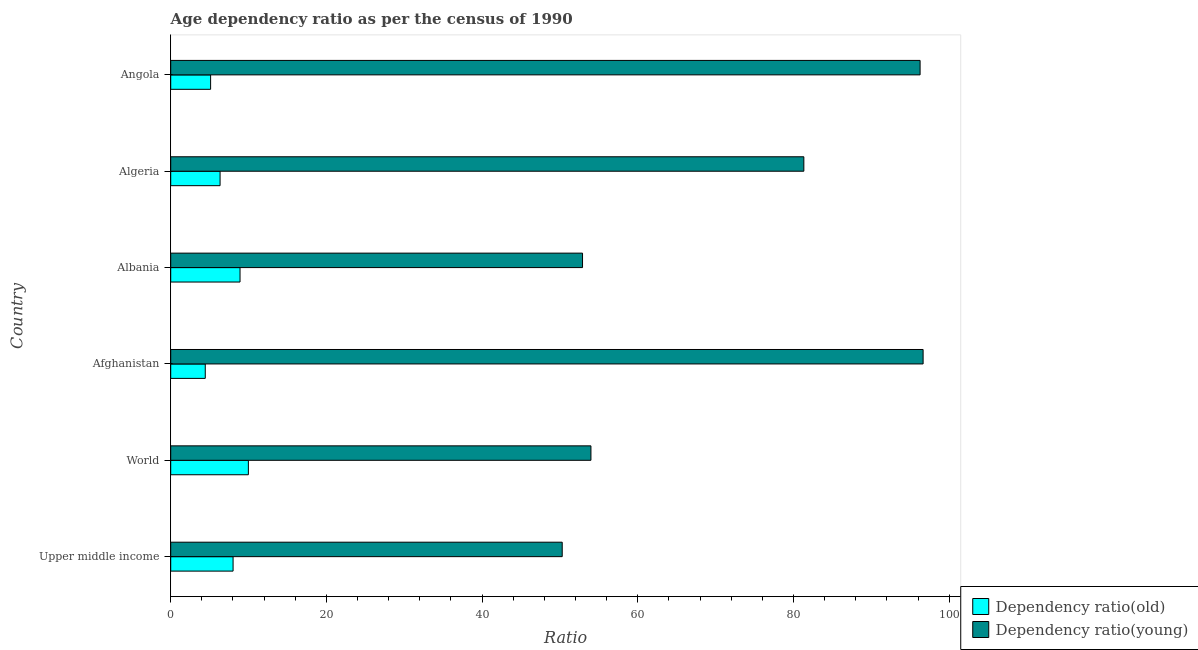How many different coloured bars are there?
Your answer should be compact. 2. What is the label of the 2nd group of bars from the top?
Your answer should be compact. Algeria. In how many cases, is the number of bars for a given country not equal to the number of legend labels?
Keep it short and to the point. 0. What is the age dependency ratio(old) in Algeria?
Your answer should be very brief. 6.34. Across all countries, what is the maximum age dependency ratio(young)?
Ensure brevity in your answer.  96.66. Across all countries, what is the minimum age dependency ratio(old)?
Offer a very short reply. 4.44. In which country was the age dependency ratio(young) maximum?
Ensure brevity in your answer.  Afghanistan. In which country was the age dependency ratio(young) minimum?
Provide a succinct answer. Upper middle income. What is the total age dependency ratio(young) in the graph?
Offer a terse response. 431.44. What is the difference between the age dependency ratio(old) in Albania and that in Algeria?
Keep it short and to the point. 2.56. What is the difference between the age dependency ratio(young) in Albania and the age dependency ratio(old) in Afghanistan?
Your answer should be compact. 48.47. What is the average age dependency ratio(young) per country?
Offer a very short reply. 71.91. What is the difference between the age dependency ratio(old) and age dependency ratio(young) in Angola?
Keep it short and to the point. -91.14. What is the ratio of the age dependency ratio(young) in Albania to that in Algeria?
Your answer should be very brief. 0.65. Is the age dependency ratio(young) in Afghanistan less than that in Upper middle income?
Offer a terse response. No. What is the difference between the highest and the second highest age dependency ratio(old)?
Provide a succinct answer. 1.07. What is the difference between the highest and the lowest age dependency ratio(old)?
Your answer should be very brief. 5.54. What does the 1st bar from the top in Upper middle income represents?
Give a very brief answer. Dependency ratio(young). What does the 2nd bar from the bottom in Upper middle income represents?
Your answer should be compact. Dependency ratio(young). Are all the bars in the graph horizontal?
Provide a succinct answer. Yes. How many countries are there in the graph?
Your answer should be compact. 6. What is the difference between two consecutive major ticks on the X-axis?
Ensure brevity in your answer.  20. Does the graph contain any zero values?
Ensure brevity in your answer.  No. Does the graph contain grids?
Offer a terse response. No. Where does the legend appear in the graph?
Ensure brevity in your answer.  Bottom right. How many legend labels are there?
Keep it short and to the point. 2. How are the legend labels stacked?
Keep it short and to the point. Vertical. What is the title of the graph?
Keep it short and to the point. Age dependency ratio as per the census of 1990. Does "Quality of trade" appear as one of the legend labels in the graph?
Offer a terse response. No. What is the label or title of the X-axis?
Provide a succinct answer. Ratio. What is the Ratio of Dependency ratio(old) in Upper middle income?
Your answer should be very brief. 8.01. What is the Ratio in Dependency ratio(young) in Upper middle income?
Keep it short and to the point. 50.29. What is the Ratio of Dependency ratio(old) in World?
Provide a short and direct response. 9.98. What is the Ratio of Dependency ratio(young) in World?
Make the answer very short. 53.98. What is the Ratio of Dependency ratio(old) in Afghanistan?
Ensure brevity in your answer.  4.44. What is the Ratio of Dependency ratio(young) in Afghanistan?
Give a very brief answer. 96.66. What is the Ratio of Dependency ratio(old) in Albania?
Offer a terse response. 8.9. What is the Ratio in Dependency ratio(young) in Albania?
Provide a succinct answer. 52.9. What is the Ratio in Dependency ratio(old) in Algeria?
Make the answer very short. 6.34. What is the Ratio in Dependency ratio(young) in Algeria?
Keep it short and to the point. 81.33. What is the Ratio in Dependency ratio(old) in Angola?
Offer a terse response. 5.13. What is the Ratio of Dependency ratio(young) in Angola?
Ensure brevity in your answer.  96.27. Across all countries, what is the maximum Ratio of Dependency ratio(old)?
Your answer should be very brief. 9.98. Across all countries, what is the maximum Ratio in Dependency ratio(young)?
Ensure brevity in your answer.  96.66. Across all countries, what is the minimum Ratio of Dependency ratio(old)?
Provide a short and direct response. 4.44. Across all countries, what is the minimum Ratio of Dependency ratio(young)?
Provide a short and direct response. 50.29. What is the total Ratio in Dependency ratio(old) in the graph?
Your answer should be compact. 42.8. What is the total Ratio in Dependency ratio(young) in the graph?
Your answer should be very brief. 431.44. What is the difference between the Ratio in Dependency ratio(old) in Upper middle income and that in World?
Ensure brevity in your answer.  -1.97. What is the difference between the Ratio in Dependency ratio(young) in Upper middle income and that in World?
Ensure brevity in your answer.  -3.69. What is the difference between the Ratio in Dependency ratio(old) in Upper middle income and that in Afghanistan?
Ensure brevity in your answer.  3.57. What is the difference between the Ratio in Dependency ratio(young) in Upper middle income and that in Afghanistan?
Give a very brief answer. -46.36. What is the difference between the Ratio of Dependency ratio(old) in Upper middle income and that in Albania?
Provide a short and direct response. -0.89. What is the difference between the Ratio in Dependency ratio(young) in Upper middle income and that in Albania?
Provide a succinct answer. -2.61. What is the difference between the Ratio of Dependency ratio(old) in Upper middle income and that in Algeria?
Make the answer very short. 1.67. What is the difference between the Ratio in Dependency ratio(young) in Upper middle income and that in Algeria?
Ensure brevity in your answer.  -31.04. What is the difference between the Ratio in Dependency ratio(old) in Upper middle income and that in Angola?
Make the answer very short. 2.89. What is the difference between the Ratio of Dependency ratio(young) in Upper middle income and that in Angola?
Keep it short and to the point. -45.98. What is the difference between the Ratio of Dependency ratio(old) in World and that in Afghanistan?
Give a very brief answer. 5.54. What is the difference between the Ratio of Dependency ratio(young) in World and that in Afghanistan?
Your response must be concise. -42.67. What is the difference between the Ratio of Dependency ratio(old) in World and that in Albania?
Make the answer very short. 1.07. What is the difference between the Ratio of Dependency ratio(young) in World and that in Albania?
Your answer should be very brief. 1.08. What is the difference between the Ratio of Dependency ratio(old) in World and that in Algeria?
Keep it short and to the point. 3.64. What is the difference between the Ratio of Dependency ratio(young) in World and that in Algeria?
Offer a terse response. -27.35. What is the difference between the Ratio of Dependency ratio(old) in World and that in Angola?
Keep it short and to the point. 4.85. What is the difference between the Ratio in Dependency ratio(young) in World and that in Angola?
Provide a short and direct response. -42.29. What is the difference between the Ratio in Dependency ratio(old) in Afghanistan and that in Albania?
Offer a very short reply. -4.47. What is the difference between the Ratio of Dependency ratio(young) in Afghanistan and that in Albania?
Provide a succinct answer. 43.75. What is the difference between the Ratio in Dependency ratio(old) in Afghanistan and that in Algeria?
Give a very brief answer. -1.9. What is the difference between the Ratio of Dependency ratio(young) in Afghanistan and that in Algeria?
Ensure brevity in your answer.  15.32. What is the difference between the Ratio in Dependency ratio(old) in Afghanistan and that in Angola?
Provide a short and direct response. -0.69. What is the difference between the Ratio of Dependency ratio(young) in Afghanistan and that in Angola?
Offer a very short reply. 0.39. What is the difference between the Ratio of Dependency ratio(old) in Albania and that in Algeria?
Offer a terse response. 2.56. What is the difference between the Ratio of Dependency ratio(young) in Albania and that in Algeria?
Your answer should be compact. -28.43. What is the difference between the Ratio in Dependency ratio(old) in Albania and that in Angola?
Ensure brevity in your answer.  3.78. What is the difference between the Ratio in Dependency ratio(young) in Albania and that in Angola?
Provide a short and direct response. -43.37. What is the difference between the Ratio of Dependency ratio(old) in Algeria and that in Angola?
Ensure brevity in your answer.  1.22. What is the difference between the Ratio of Dependency ratio(young) in Algeria and that in Angola?
Your answer should be compact. -14.94. What is the difference between the Ratio of Dependency ratio(old) in Upper middle income and the Ratio of Dependency ratio(young) in World?
Keep it short and to the point. -45.97. What is the difference between the Ratio in Dependency ratio(old) in Upper middle income and the Ratio in Dependency ratio(young) in Afghanistan?
Make the answer very short. -88.64. What is the difference between the Ratio in Dependency ratio(old) in Upper middle income and the Ratio in Dependency ratio(young) in Albania?
Provide a succinct answer. -44.89. What is the difference between the Ratio of Dependency ratio(old) in Upper middle income and the Ratio of Dependency ratio(young) in Algeria?
Keep it short and to the point. -73.32. What is the difference between the Ratio of Dependency ratio(old) in Upper middle income and the Ratio of Dependency ratio(young) in Angola?
Keep it short and to the point. -88.26. What is the difference between the Ratio of Dependency ratio(old) in World and the Ratio of Dependency ratio(young) in Afghanistan?
Keep it short and to the point. -86.68. What is the difference between the Ratio of Dependency ratio(old) in World and the Ratio of Dependency ratio(young) in Albania?
Offer a terse response. -42.93. What is the difference between the Ratio of Dependency ratio(old) in World and the Ratio of Dependency ratio(young) in Algeria?
Offer a very short reply. -71.36. What is the difference between the Ratio of Dependency ratio(old) in World and the Ratio of Dependency ratio(young) in Angola?
Offer a terse response. -86.29. What is the difference between the Ratio in Dependency ratio(old) in Afghanistan and the Ratio in Dependency ratio(young) in Albania?
Provide a succinct answer. -48.47. What is the difference between the Ratio in Dependency ratio(old) in Afghanistan and the Ratio in Dependency ratio(young) in Algeria?
Give a very brief answer. -76.9. What is the difference between the Ratio of Dependency ratio(old) in Afghanistan and the Ratio of Dependency ratio(young) in Angola?
Give a very brief answer. -91.83. What is the difference between the Ratio in Dependency ratio(old) in Albania and the Ratio in Dependency ratio(young) in Algeria?
Provide a succinct answer. -72.43. What is the difference between the Ratio in Dependency ratio(old) in Albania and the Ratio in Dependency ratio(young) in Angola?
Provide a short and direct response. -87.37. What is the difference between the Ratio of Dependency ratio(old) in Algeria and the Ratio of Dependency ratio(young) in Angola?
Offer a terse response. -89.93. What is the average Ratio in Dependency ratio(old) per country?
Your response must be concise. 7.13. What is the average Ratio of Dependency ratio(young) per country?
Make the answer very short. 71.91. What is the difference between the Ratio of Dependency ratio(old) and Ratio of Dependency ratio(young) in Upper middle income?
Make the answer very short. -42.28. What is the difference between the Ratio in Dependency ratio(old) and Ratio in Dependency ratio(young) in World?
Your answer should be very brief. -44.01. What is the difference between the Ratio of Dependency ratio(old) and Ratio of Dependency ratio(young) in Afghanistan?
Offer a very short reply. -92.22. What is the difference between the Ratio in Dependency ratio(old) and Ratio in Dependency ratio(young) in Albania?
Your answer should be compact. -44. What is the difference between the Ratio in Dependency ratio(old) and Ratio in Dependency ratio(young) in Algeria?
Provide a short and direct response. -74.99. What is the difference between the Ratio in Dependency ratio(old) and Ratio in Dependency ratio(young) in Angola?
Ensure brevity in your answer.  -91.14. What is the ratio of the Ratio in Dependency ratio(old) in Upper middle income to that in World?
Provide a short and direct response. 0.8. What is the ratio of the Ratio in Dependency ratio(young) in Upper middle income to that in World?
Your answer should be very brief. 0.93. What is the ratio of the Ratio in Dependency ratio(old) in Upper middle income to that in Afghanistan?
Provide a succinct answer. 1.81. What is the ratio of the Ratio in Dependency ratio(young) in Upper middle income to that in Afghanistan?
Your answer should be very brief. 0.52. What is the ratio of the Ratio in Dependency ratio(old) in Upper middle income to that in Albania?
Provide a short and direct response. 0.9. What is the ratio of the Ratio of Dependency ratio(young) in Upper middle income to that in Albania?
Give a very brief answer. 0.95. What is the ratio of the Ratio of Dependency ratio(old) in Upper middle income to that in Algeria?
Ensure brevity in your answer.  1.26. What is the ratio of the Ratio of Dependency ratio(young) in Upper middle income to that in Algeria?
Your answer should be compact. 0.62. What is the ratio of the Ratio of Dependency ratio(old) in Upper middle income to that in Angola?
Provide a succinct answer. 1.56. What is the ratio of the Ratio in Dependency ratio(young) in Upper middle income to that in Angola?
Provide a short and direct response. 0.52. What is the ratio of the Ratio in Dependency ratio(old) in World to that in Afghanistan?
Offer a terse response. 2.25. What is the ratio of the Ratio of Dependency ratio(young) in World to that in Afghanistan?
Your answer should be very brief. 0.56. What is the ratio of the Ratio in Dependency ratio(old) in World to that in Albania?
Your response must be concise. 1.12. What is the ratio of the Ratio in Dependency ratio(young) in World to that in Albania?
Make the answer very short. 1.02. What is the ratio of the Ratio of Dependency ratio(old) in World to that in Algeria?
Ensure brevity in your answer.  1.57. What is the ratio of the Ratio in Dependency ratio(young) in World to that in Algeria?
Make the answer very short. 0.66. What is the ratio of the Ratio of Dependency ratio(old) in World to that in Angola?
Keep it short and to the point. 1.95. What is the ratio of the Ratio in Dependency ratio(young) in World to that in Angola?
Provide a short and direct response. 0.56. What is the ratio of the Ratio in Dependency ratio(old) in Afghanistan to that in Albania?
Your answer should be very brief. 0.5. What is the ratio of the Ratio of Dependency ratio(young) in Afghanistan to that in Albania?
Provide a short and direct response. 1.83. What is the ratio of the Ratio of Dependency ratio(old) in Afghanistan to that in Algeria?
Offer a very short reply. 0.7. What is the ratio of the Ratio of Dependency ratio(young) in Afghanistan to that in Algeria?
Your answer should be compact. 1.19. What is the ratio of the Ratio of Dependency ratio(old) in Afghanistan to that in Angola?
Your answer should be very brief. 0.87. What is the ratio of the Ratio in Dependency ratio(young) in Afghanistan to that in Angola?
Provide a short and direct response. 1. What is the ratio of the Ratio of Dependency ratio(old) in Albania to that in Algeria?
Ensure brevity in your answer.  1.4. What is the ratio of the Ratio in Dependency ratio(young) in Albania to that in Algeria?
Make the answer very short. 0.65. What is the ratio of the Ratio in Dependency ratio(old) in Albania to that in Angola?
Provide a succinct answer. 1.74. What is the ratio of the Ratio of Dependency ratio(young) in Albania to that in Angola?
Provide a short and direct response. 0.55. What is the ratio of the Ratio in Dependency ratio(old) in Algeria to that in Angola?
Ensure brevity in your answer.  1.24. What is the ratio of the Ratio of Dependency ratio(young) in Algeria to that in Angola?
Offer a very short reply. 0.84. What is the difference between the highest and the second highest Ratio in Dependency ratio(old)?
Ensure brevity in your answer.  1.07. What is the difference between the highest and the second highest Ratio of Dependency ratio(young)?
Provide a short and direct response. 0.39. What is the difference between the highest and the lowest Ratio of Dependency ratio(old)?
Your answer should be very brief. 5.54. What is the difference between the highest and the lowest Ratio of Dependency ratio(young)?
Offer a very short reply. 46.36. 